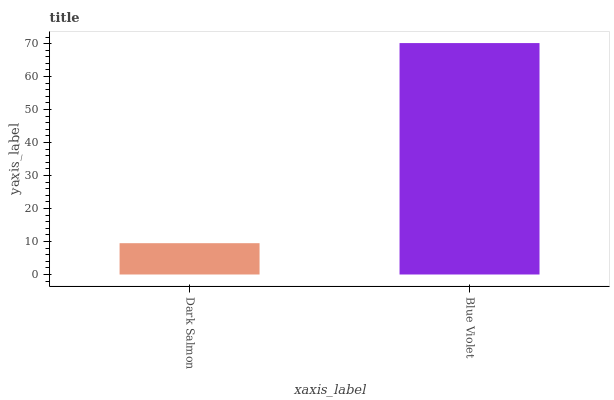Is Dark Salmon the minimum?
Answer yes or no. Yes. Is Blue Violet the maximum?
Answer yes or no. Yes. Is Blue Violet the minimum?
Answer yes or no. No. Is Blue Violet greater than Dark Salmon?
Answer yes or no. Yes. Is Dark Salmon less than Blue Violet?
Answer yes or no. Yes. Is Dark Salmon greater than Blue Violet?
Answer yes or no. No. Is Blue Violet less than Dark Salmon?
Answer yes or no. No. Is Blue Violet the high median?
Answer yes or no. Yes. Is Dark Salmon the low median?
Answer yes or no. Yes. Is Dark Salmon the high median?
Answer yes or no. No. Is Blue Violet the low median?
Answer yes or no. No. 